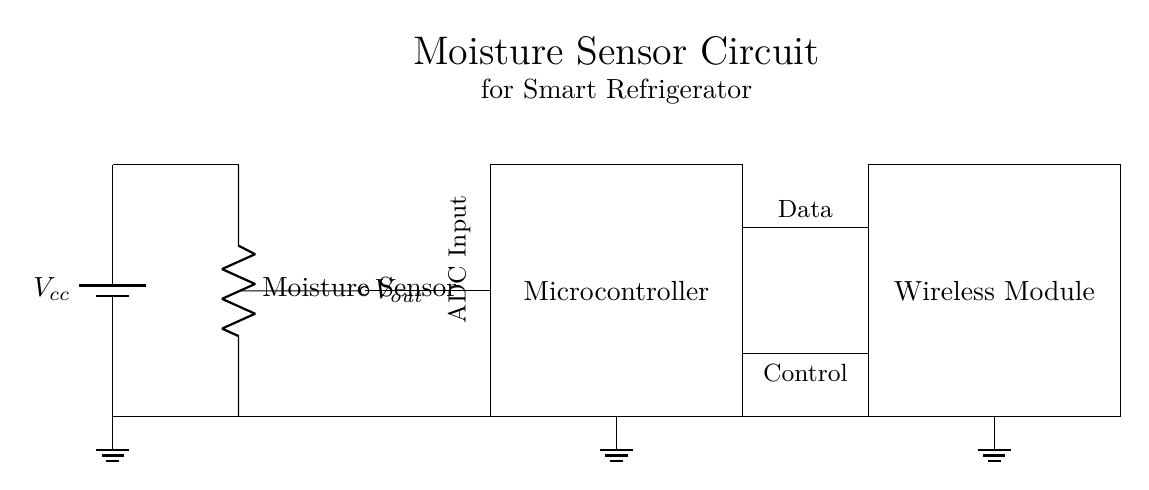What type of sensor is used in this circuit? The circuit diagram shows a moisture sensor, which is indicated clearly along the vertical component labeled "Moisture Sensor".
Answer: Moisture Sensor What is the purpose of the microcontroller? The microcontroller controls the operations of the circuit, as depicted by its central location and the label "Microcontroller" within the rectangle. It processes data received from the moisture sensor.
Answer: Control operations What is the output voltage denoted in the circuit? The output voltage is marked as "Vout" which is connected to the moisture sensor and indicates the measured output from it.
Answer: Vout How many ground connections are there? There are three ground connections as indicated by the nodes at the bottom of the circuit. Each major component has a ground connection shown.
Answer: Three What type of communication is indicated between the microcontroller and the wireless module? The circuit shows connections labeled "Data" and "Control" between the microcontroller and the wireless module, indicating a bi-directional communication setup.
Answer: Data and Control What is the function of the voltage divider in this circuit? The voltage divider is used to provide a specific voltage output based on the moisture sensor's readings, which ultimately allows the microcontroller to interpret the sensor data accurately.
Answer: To provide output voltage 